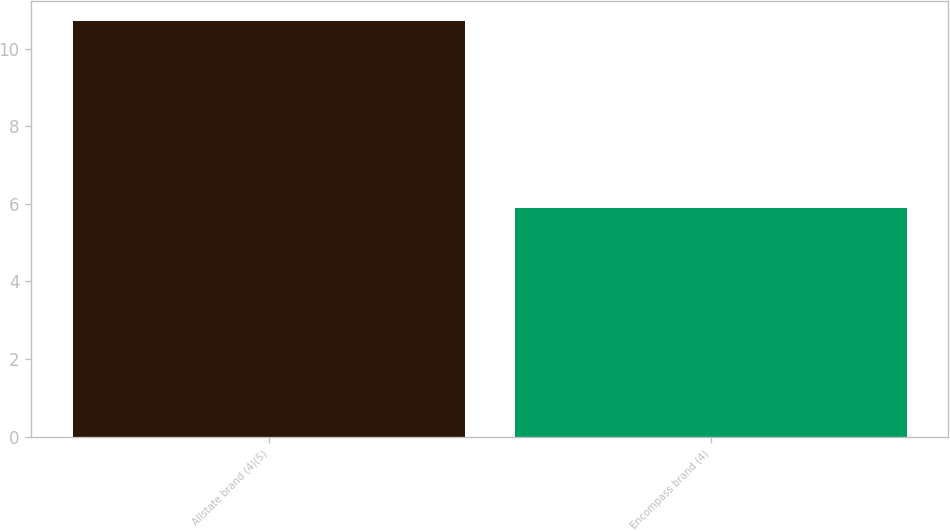Convert chart to OTSL. <chart><loc_0><loc_0><loc_500><loc_500><bar_chart><fcel>Allstate brand (4)(5)<fcel>Encompass brand (4)<nl><fcel>10.7<fcel>5.9<nl></chart> 